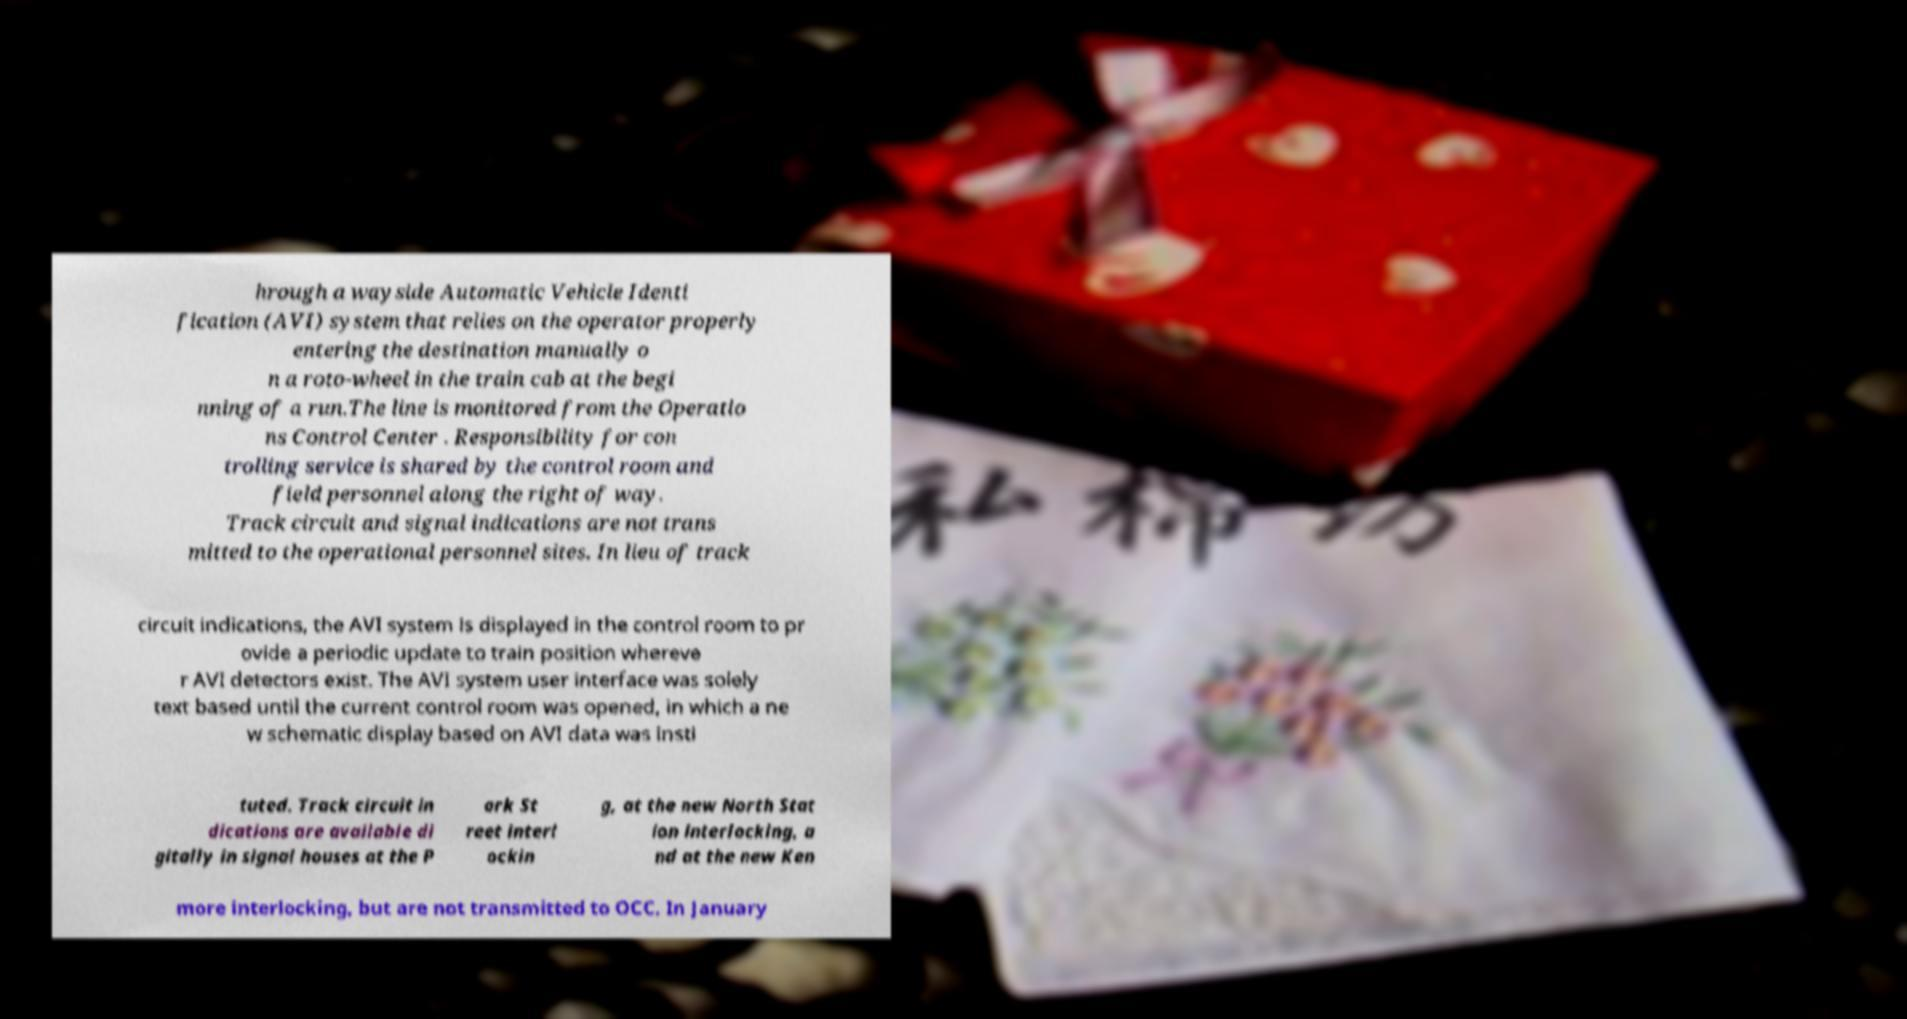There's text embedded in this image that I need extracted. Can you transcribe it verbatim? hrough a wayside Automatic Vehicle Identi fication (AVI) system that relies on the operator properly entering the destination manually o n a roto-wheel in the train cab at the begi nning of a run.The line is monitored from the Operatio ns Control Center . Responsibility for con trolling service is shared by the control room and field personnel along the right of way. Track circuit and signal indications are not trans mitted to the operational personnel sites. In lieu of track circuit indications, the AVI system is displayed in the control room to pr ovide a periodic update to train position whereve r AVI detectors exist. The AVI system user interface was solely text based until the current control room was opened, in which a ne w schematic display based on AVI data was insti tuted. Track circuit in dications are available di gitally in signal houses at the P ark St reet interl ockin g, at the new North Stat ion interlocking, a nd at the new Ken more interlocking, but are not transmitted to OCC. In January 